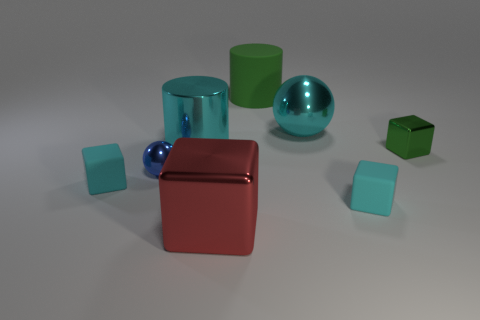Add 1 large shiny spheres. How many objects exist? 9 Subtract all balls. How many objects are left? 6 Add 4 big cyan metal things. How many big cyan metal things are left? 6 Add 8 small blue cylinders. How many small blue cylinders exist? 8 Subtract 0 gray spheres. How many objects are left? 8 Subtract all green cylinders. Subtract all red blocks. How many objects are left? 6 